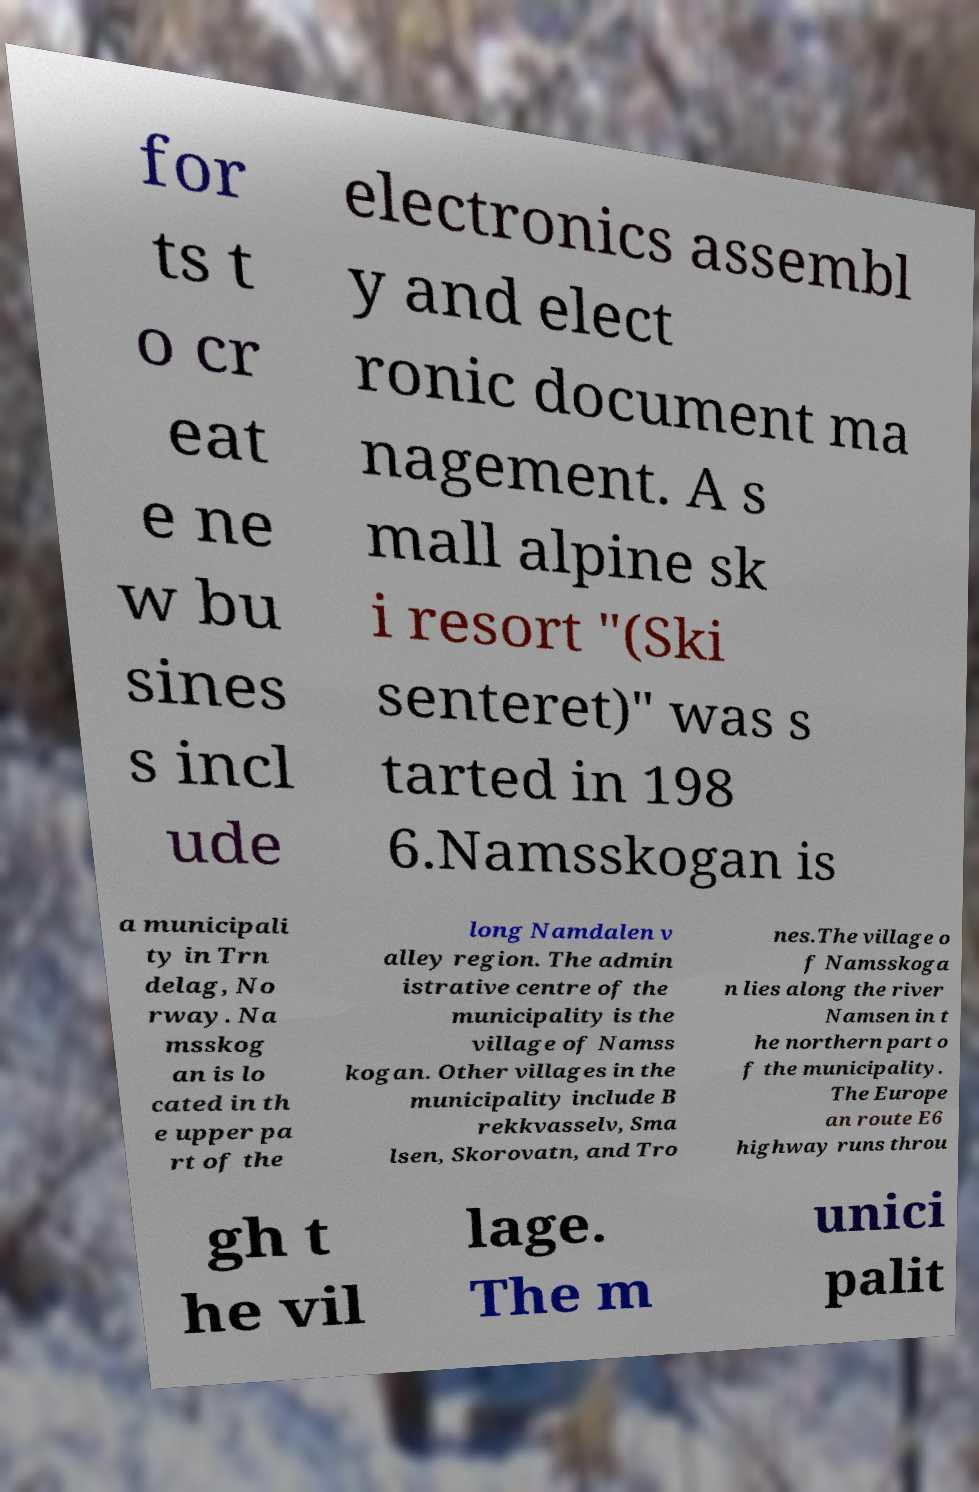For documentation purposes, I need the text within this image transcribed. Could you provide that? for ts t o cr eat e ne w bu sines s incl ude electronics assembl y and elect ronic document ma nagement. A s mall alpine sk i resort "(Ski senteret)" was s tarted in 198 6.Namsskogan is a municipali ty in Trn delag, No rway. Na msskog an is lo cated in th e upper pa rt of the long Namdalen v alley region. The admin istrative centre of the municipality is the village of Namss kogan. Other villages in the municipality include B rekkvasselv, Sma lsen, Skorovatn, and Tro nes.The village o f Namsskoga n lies along the river Namsen in t he northern part o f the municipality. The Europe an route E6 highway runs throu gh t he vil lage. The m unici palit 